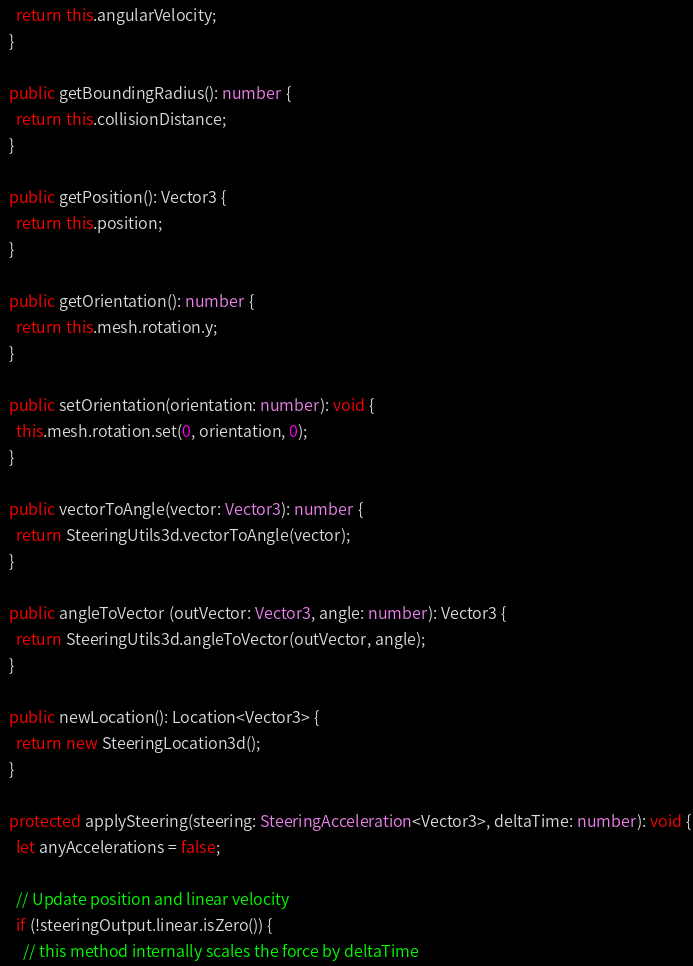Convert code to text. <code><loc_0><loc_0><loc_500><loc_500><_TypeScript_>    return this.angularVelocity;
  }

  public getBoundingRadius(): number {
    return this.collisionDistance;
  }

  public getPosition(): Vector3 {
    return this.position;
  }

  public getOrientation(): number {
    return this.mesh.rotation.y;
  }

  public setOrientation(orientation: number): void {
    this.mesh.rotation.set(0, orientation, 0);
  }

  public vectorToAngle(vector: Vector3): number {
    return SteeringUtils3d.vectorToAngle(vector);
  }

  public angleToVector (outVector: Vector3, angle: number): Vector3 {
    return SteeringUtils3d.angleToVector(outVector, angle);
  }

  public newLocation(): Location<Vector3> {
    return new SteeringLocation3d();
  }

  protected applySteering(steering: SteeringAcceleration<Vector3>, deltaTime: number): void {
    let anyAccelerations = false;

    // Update position and linear velocity
    if (!steeringOutput.linear.isZero()) {
      // this method internally scales the force by deltaTime</code> 